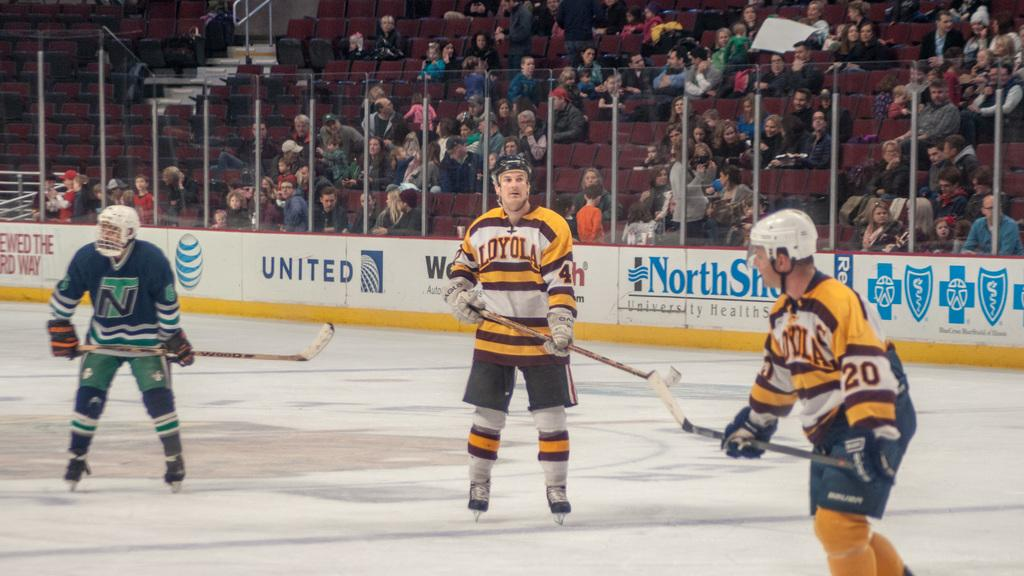How many men are in the image? There are three men in the image. What are the men holding in the image? The men are holding hockey sticks. Where are the men standing in the image? The men are standing on an ice floor. What can be observed about the audience members in the image? There are many audience members in the image, and they are sitting on chairs. What are the audience members doing in the image? The audience members are looking at the game. What type of print can be seen on the hockey sticks in the image? There is no specific print mentioned on the hockey sticks in the image; only the fact that the men are holding hockey sticks is provided. Is there a fight breaking out among the audience members in the image? There is no indication of a fight among the audience members in the image; they are sitting and watching the game. 